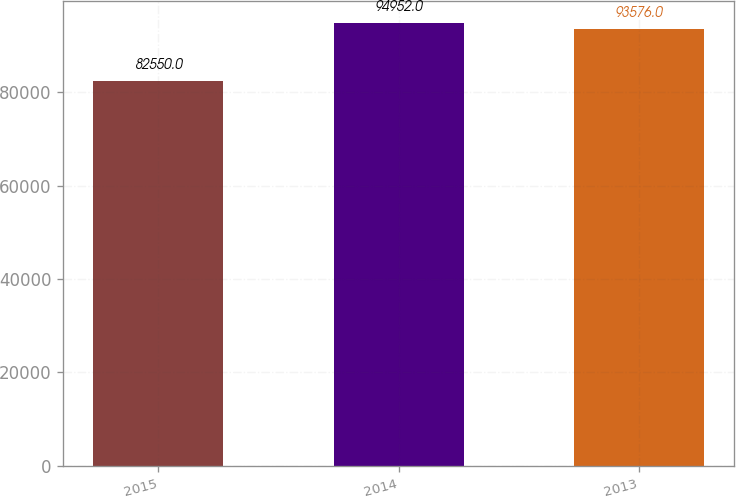Convert chart to OTSL. <chart><loc_0><loc_0><loc_500><loc_500><bar_chart><fcel>2015<fcel>2014<fcel>2013<nl><fcel>82550<fcel>94952<fcel>93576<nl></chart> 